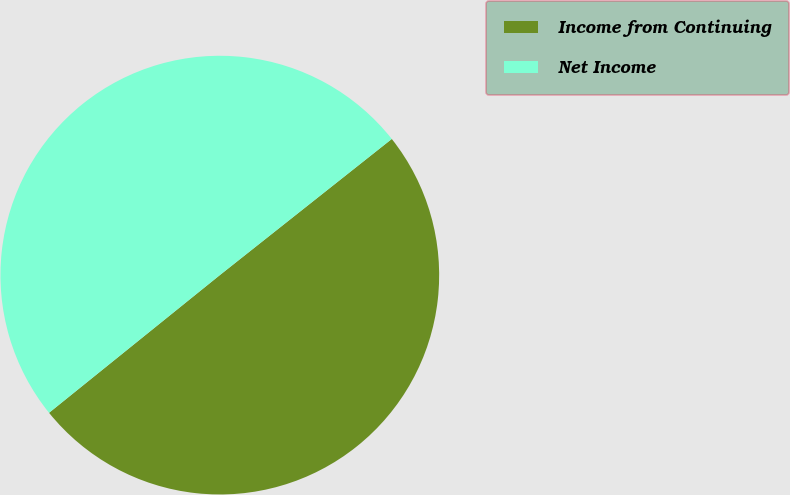Convert chart. <chart><loc_0><loc_0><loc_500><loc_500><pie_chart><fcel>Income from Continuing<fcel>Net Income<nl><fcel>49.86%<fcel>50.14%<nl></chart> 